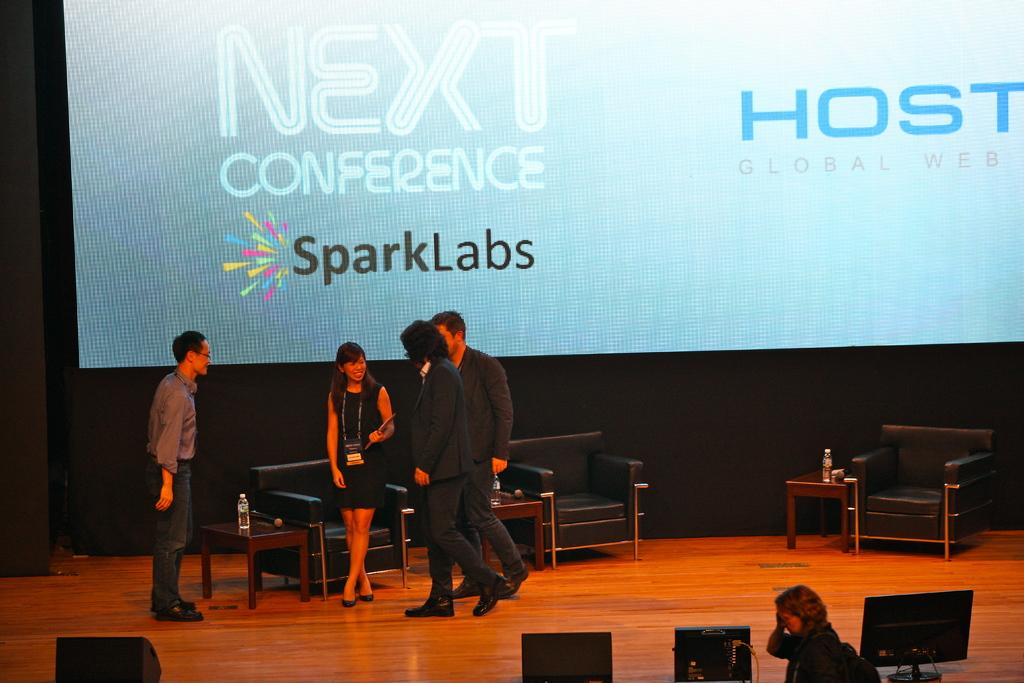How many people are on the stage in the image? There are four people standing on a stage in the image. What else can be seen in the image besides the people on the stage? There is a table in the image, and a bottle is on the table. What is visible in the background of the image? There is a poster visible in the background. What type of screw is being used by the servant in the image? There is no screw or servant present in the image. What is the plot of the story being told in the image? The image does not depict a story or plot; it shows four people on a stage, a table with a bottle, and a poster in the background. 